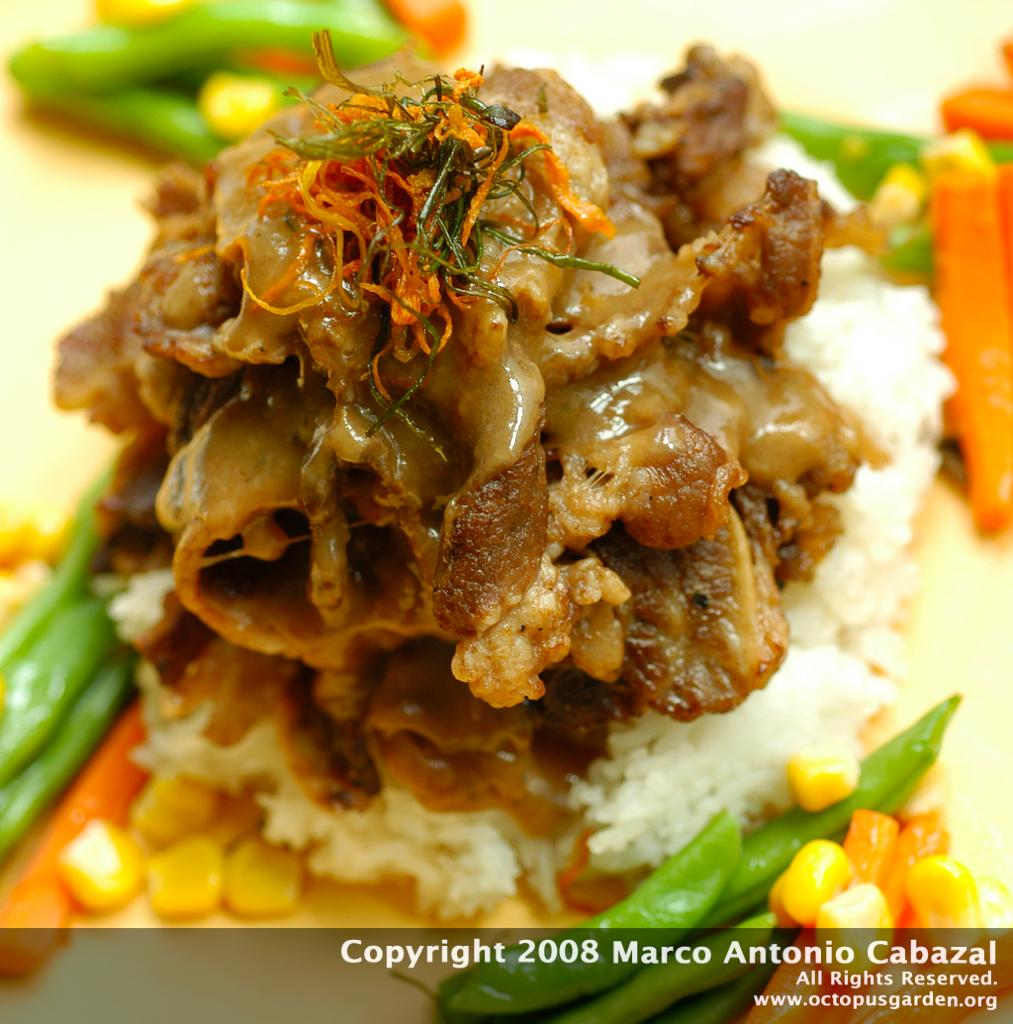What types of items can be seen in the image? There are food items in the image. Where are the food items located? The food items are on an object. Is there any additional information or marking on the image? Yes, there is a watermark on the image. What type of curtain can be seen hanging in the image? There is no curtain present in the image. 